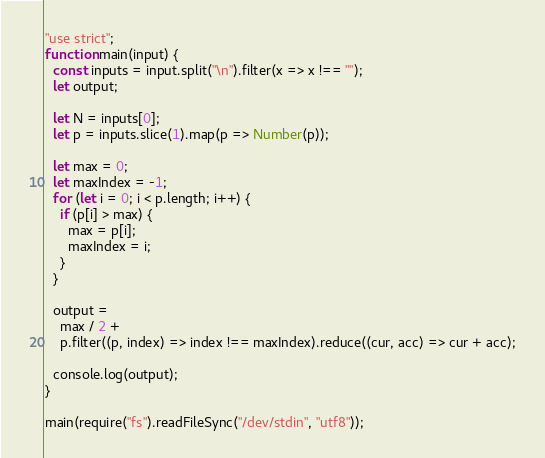Convert code to text. <code><loc_0><loc_0><loc_500><loc_500><_JavaScript_>"use strict";
function main(input) {
  const inputs = input.split("\n").filter(x => x !== "");
  let output;

  let N = inputs[0];
  let p = inputs.slice(1).map(p => Number(p));

  let max = 0;
  let maxIndex = -1;
  for (let i = 0; i < p.length; i++) {
    if (p[i] > max) {
      max = p[i];
      maxIndex = i;
    }
  }

  output =
    max / 2 +
    p.filter((p, index) => index !== maxIndex).reduce((cur, acc) => cur + acc);

  console.log(output);
}

main(require("fs").readFileSync("/dev/stdin", "utf8"));
</code> 